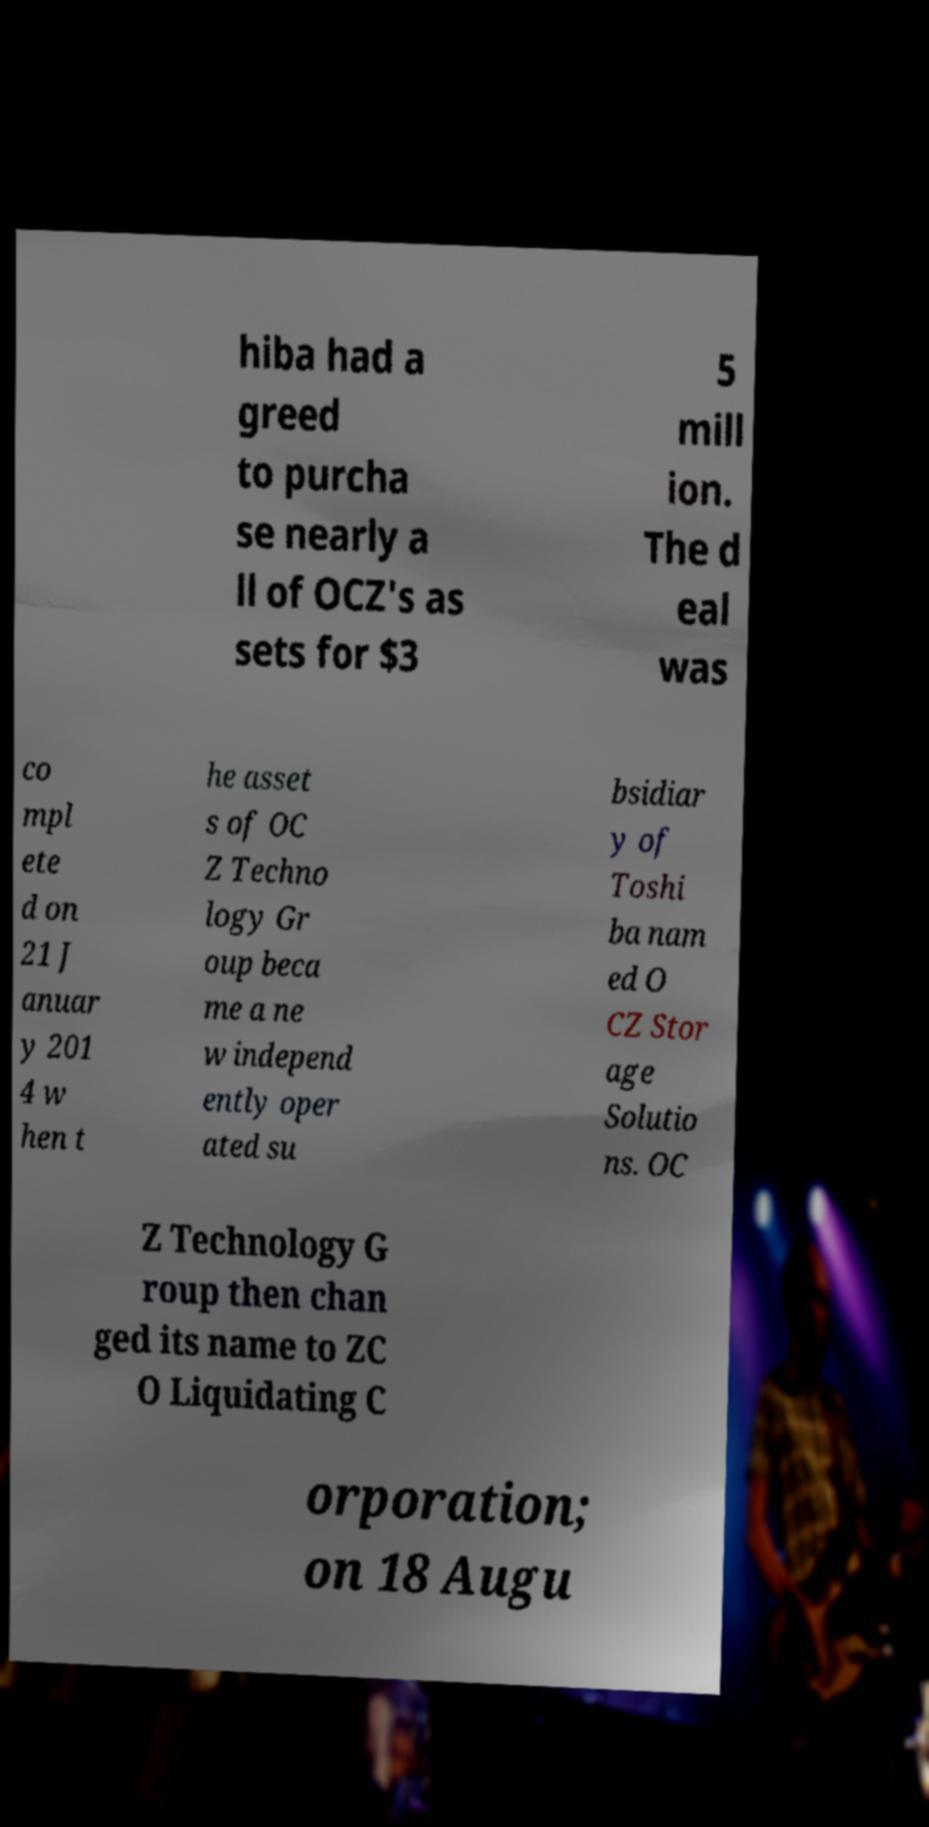Could you assist in decoding the text presented in this image and type it out clearly? hiba had a greed to purcha se nearly a ll of OCZ's as sets for $3 5 mill ion. The d eal was co mpl ete d on 21 J anuar y 201 4 w hen t he asset s of OC Z Techno logy Gr oup beca me a ne w independ ently oper ated su bsidiar y of Toshi ba nam ed O CZ Stor age Solutio ns. OC Z Technology G roup then chan ged its name to ZC O Liquidating C orporation; on 18 Augu 